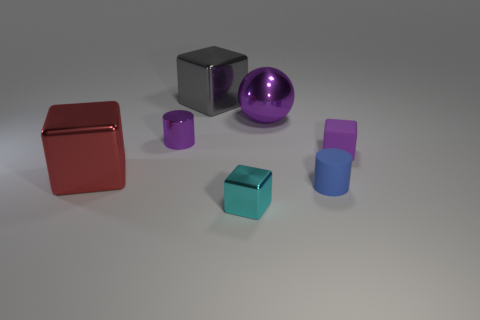There is another tiny object that is the same shape as the small cyan object; what is its material?
Keep it short and to the point. Rubber. What number of other things are the same shape as the purple rubber thing?
Offer a very short reply. 3. What number of small purple matte cubes are behind the large red shiny object on the left side of the small block behind the red object?
Your answer should be very brief. 1. What number of tiny blue things are the same shape as the red object?
Give a very brief answer. 0. Is the color of the big metal thing right of the large gray shiny block the same as the metallic cylinder?
Provide a succinct answer. Yes. There is a small purple object right of the cylinder that is in front of the cylinder behind the rubber block; what is its shape?
Your answer should be compact. Cube. Is the size of the red metallic cube the same as the cylinder to the left of the tiny blue rubber object?
Ensure brevity in your answer.  No. Are there any gray shiny blocks of the same size as the purple ball?
Offer a terse response. Yes. How many other objects are the same material as the cyan object?
Give a very brief answer. 4. The thing that is both left of the rubber cylinder and right of the cyan metallic block is what color?
Give a very brief answer. Purple. 